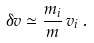<formula> <loc_0><loc_0><loc_500><loc_500>\delta { v } \simeq \frac { m _ { i } } { m } \, { v } _ { i } \, .</formula> 